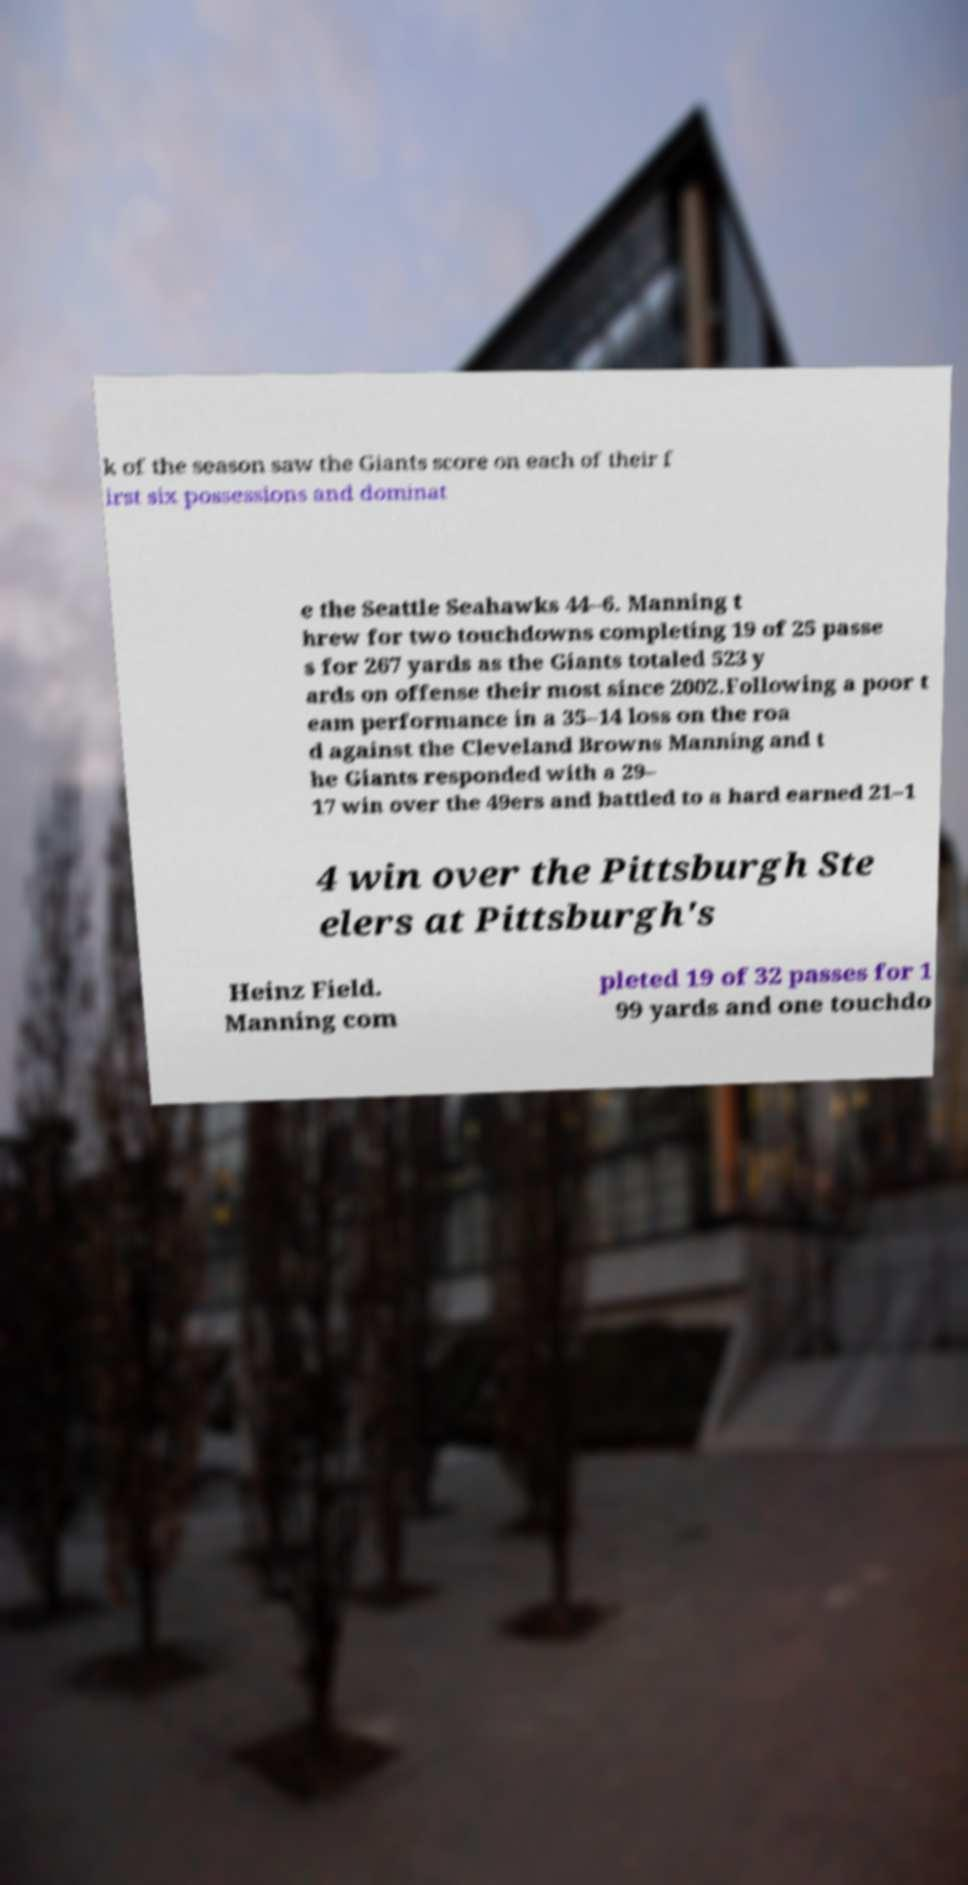What messages or text are displayed in this image? I need them in a readable, typed format. k of the season saw the Giants score on each of their f irst six possessions and dominat e the Seattle Seahawks 44–6. Manning t hrew for two touchdowns completing 19 of 25 passe s for 267 yards as the Giants totaled 523 y ards on offense their most since 2002.Following a poor t eam performance in a 35–14 loss on the roa d against the Cleveland Browns Manning and t he Giants responded with a 29– 17 win over the 49ers and battled to a hard earned 21–1 4 win over the Pittsburgh Ste elers at Pittsburgh's Heinz Field. Manning com pleted 19 of 32 passes for 1 99 yards and one touchdo 